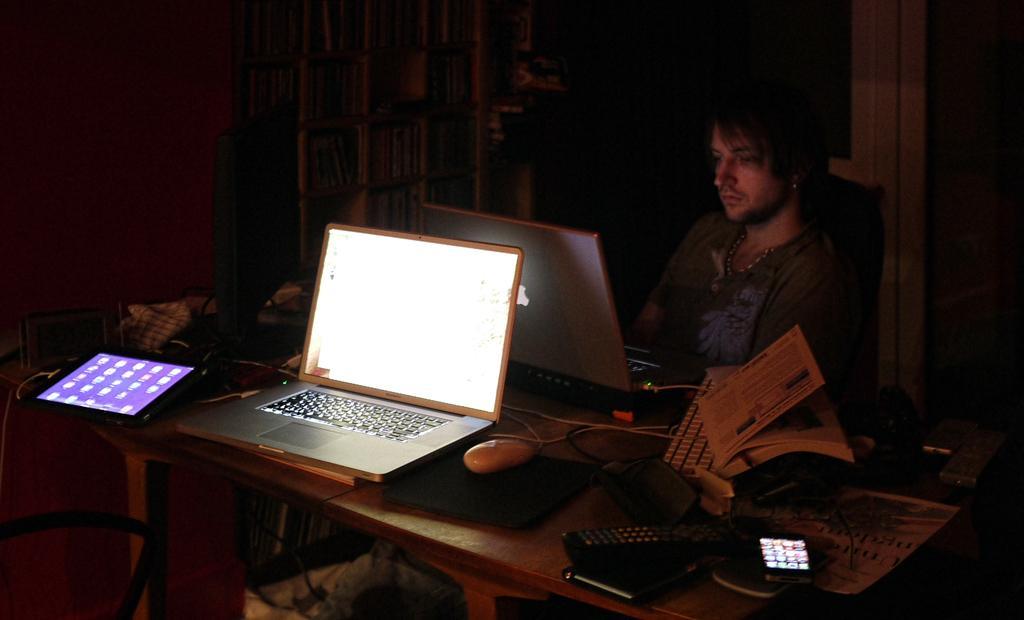Could you give a brief overview of what you see in this image? In a room there is a laptop and the person sitting behind it operating with it and there is a table with a other laptop tab and some books with the cellphone on the table. 